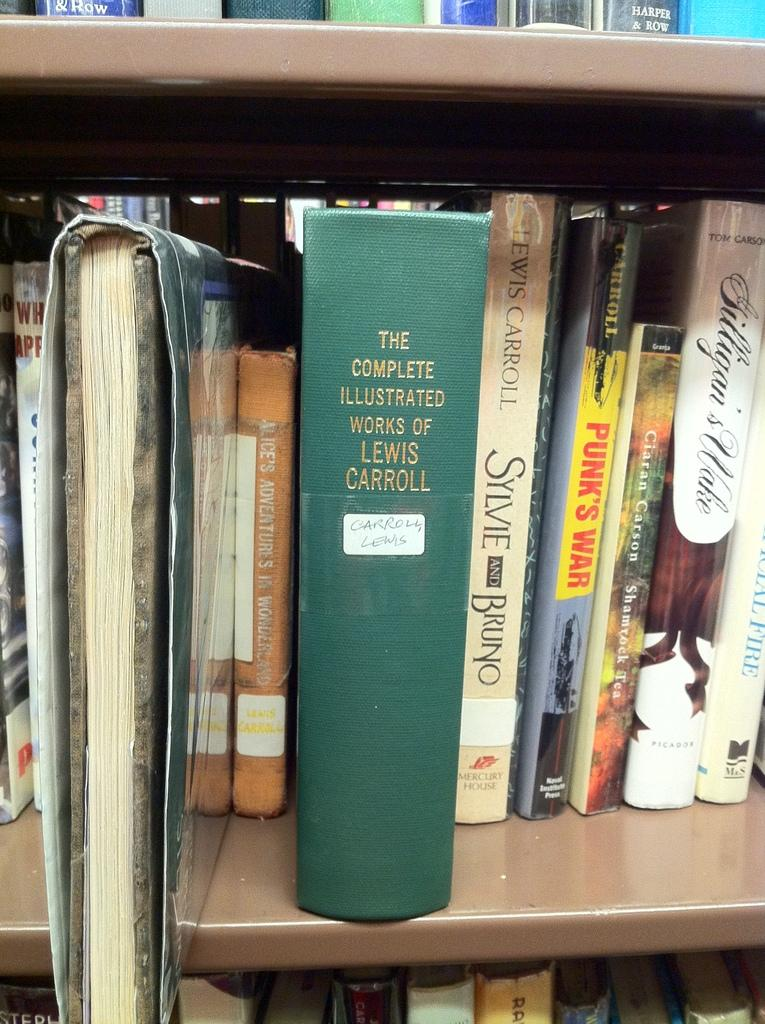<image>
Write a terse but informative summary of the picture. The Lewis Carroll book is one of the books on the shelf. 